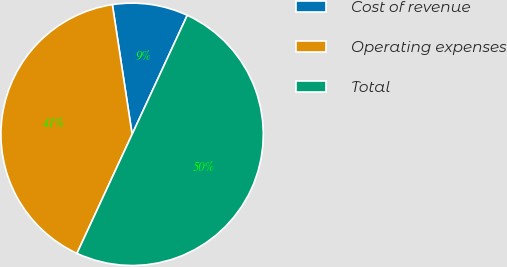<chart> <loc_0><loc_0><loc_500><loc_500><pie_chart><fcel>Cost of revenue<fcel>Operating expenses<fcel>Total<nl><fcel>9.31%<fcel>40.69%<fcel>50.0%<nl></chart> 